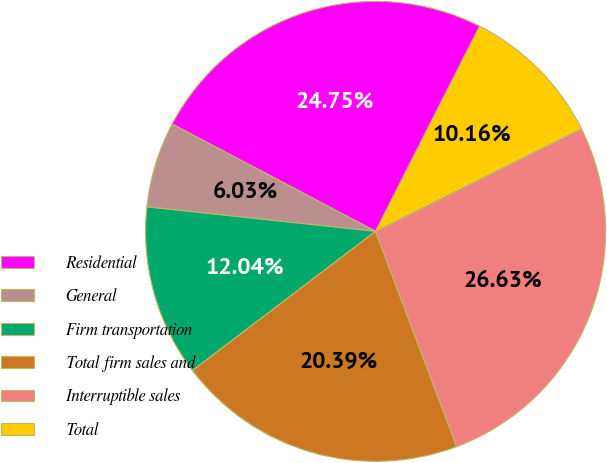<chart> <loc_0><loc_0><loc_500><loc_500><pie_chart><fcel>Residential<fcel>General<fcel>Firm transportation<fcel>Total firm sales and<fcel>Interruptible sales<fcel>Total<nl><fcel>24.75%<fcel>6.03%<fcel>12.04%<fcel>20.39%<fcel>26.63%<fcel>10.16%<nl></chart> 